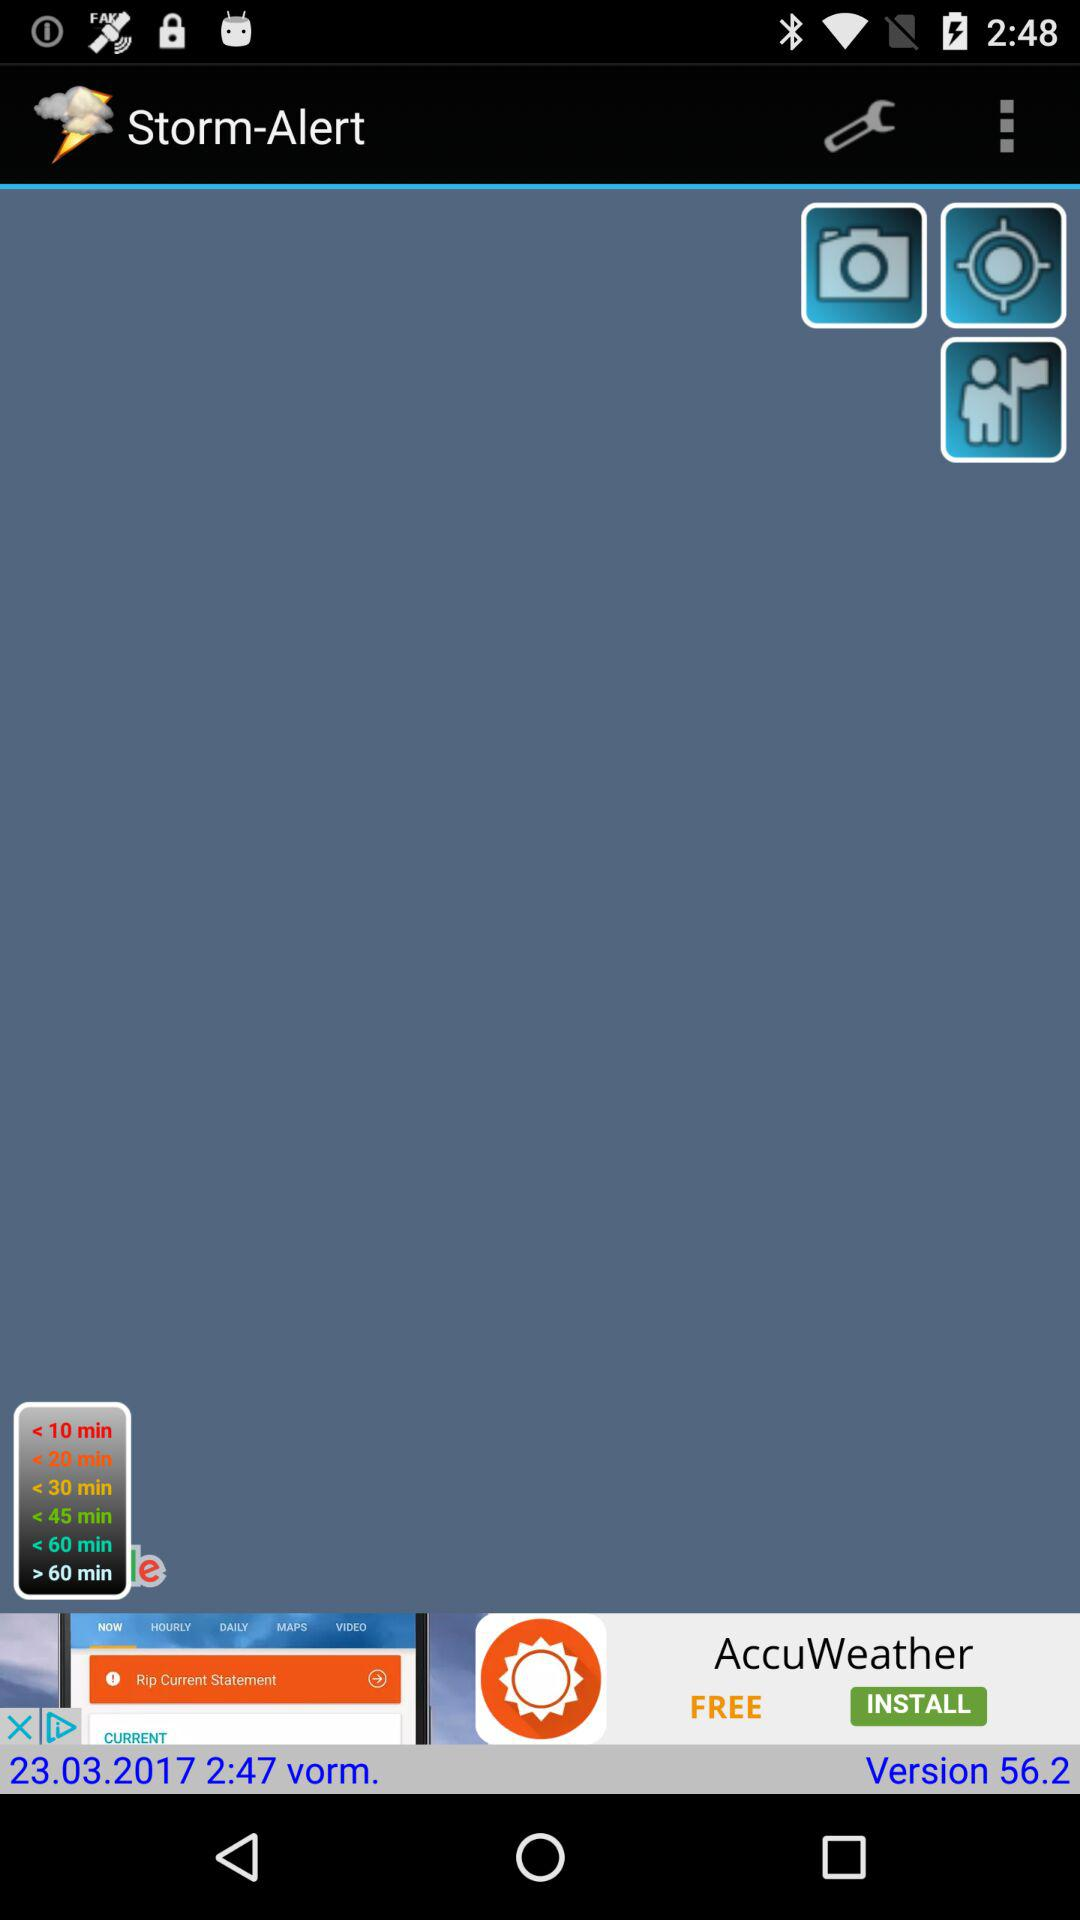What is the date mentioned in the app? The mentioned date in the app is March 23, 2017. 